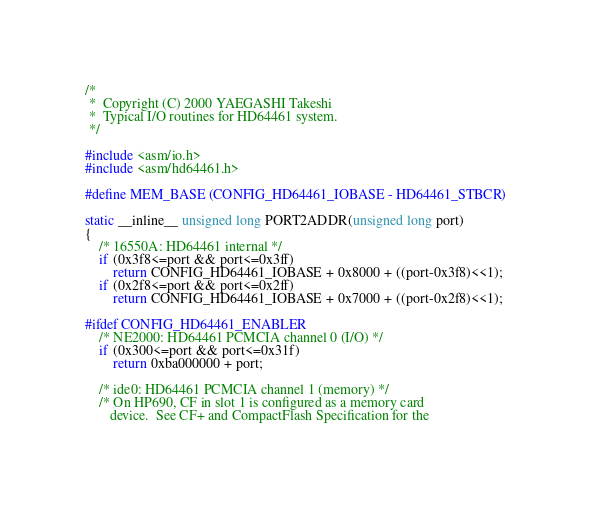Convert code to text. <code><loc_0><loc_0><loc_500><loc_500><_C_>/*
 *	Copyright (C) 2000 YAEGASHI Takeshi
 *	Typical I/O routines for HD64461 system.
 */

#include <asm/io.h>
#include <asm/hd64461.h>

#define MEM_BASE (CONFIG_HD64461_IOBASE - HD64461_STBCR)

static __inline__ unsigned long PORT2ADDR(unsigned long port)
{
	/* 16550A: HD64461 internal */
	if (0x3f8<=port && port<=0x3ff)
		return CONFIG_HD64461_IOBASE + 0x8000 + ((port-0x3f8)<<1);
	if (0x2f8<=port && port<=0x2ff)
		return CONFIG_HD64461_IOBASE + 0x7000 + ((port-0x2f8)<<1);

#ifdef CONFIG_HD64461_ENABLER
	/* NE2000: HD64461 PCMCIA channel 0 (I/O) */
	if (0x300<=port && port<=0x31f)
		return 0xba000000 + port;

	/* ide0: HD64461 PCMCIA channel 1 (memory) */
	/* On HP690, CF in slot 1 is configured as a memory card
	   device.  See CF+ and CompactFlash Specification for the</code> 